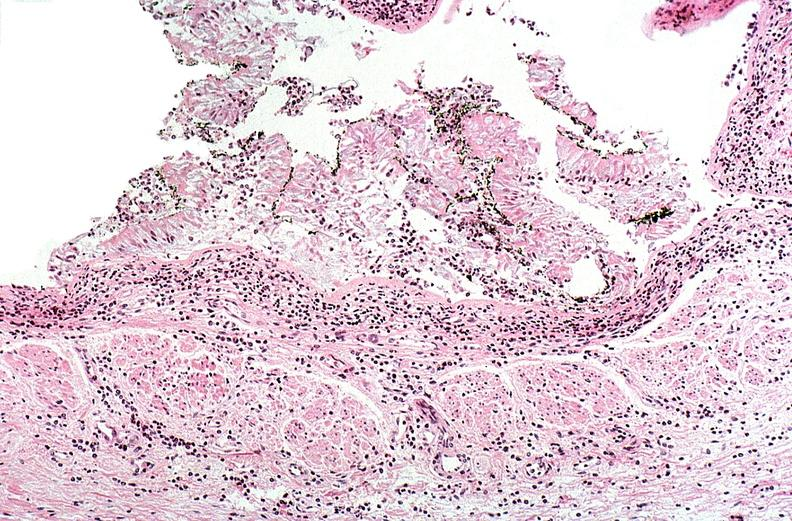do the tumor burn?
Answer the question using a single word or phrase. No 